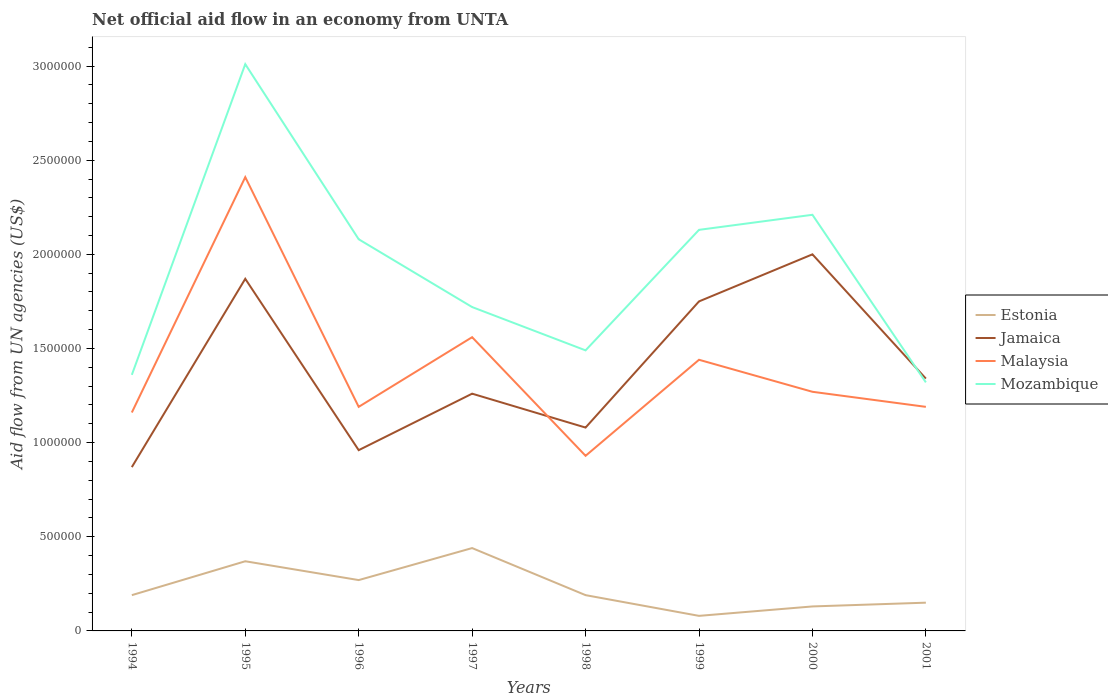Does the line corresponding to Jamaica intersect with the line corresponding to Estonia?
Your response must be concise. No. Is the number of lines equal to the number of legend labels?
Your answer should be very brief. Yes. Across all years, what is the maximum net official aid flow in Mozambique?
Offer a terse response. 1.32e+06. What is the total net official aid flow in Jamaica in the graph?
Your answer should be compact. -4.90e+05. What is the difference between the highest and the second highest net official aid flow in Malaysia?
Keep it short and to the point. 1.48e+06. Are the values on the major ticks of Y-axis written in scientific E-notation?
Provide a succinct answer. No. Does the graph contain any zero values?
Offer a very short reply. No. Does the graph contain grids?
Your answer should be compact. No. How are the legend labels stacked?
Provide a succinct answer. Vertical. What is the title of the graph?
Give a very brief answer. Net official aid flow in an economy from UNTA. What is the label or title of the Y-axis?
Make the answer very short. Aid flow from UN agencies (US$). What is the Aid flow from UN agencies (US$) of Jamaica in 1994?
Offer a very short reply. 8.70e+05. What is the Aid flow from UN agencies (US$) in Malaysia in 1994?
Keep it short and to the point. 1.16e+06. What is the Aid flow from UN agencies (US$) in Mozambique in 1994?
Make the answer very short. 1.36e+06. What is the Aid flow from UN agencies (US$) of Estonia in 1995?
Give a very brief answer. 3.70e+05. What is the Aid flow from UN agencies (US$) of Jamaica in 1995?
Ensure brevity in your answer.  1.87e+06. What is the Aid flow from UN agencies (US$) of Malaysia in 1995?
Provide a succinct answer. 2.41e+06. What is the Aid flow from UN agencies (US$) of Mozambique in 1995?
Ensure brevity in your answer.  3.01e+06. What is the Aid flow from UN agencies (US$) in Jamaica in 1996?
Your answer should be very brief. 9.60e+05. What is the Aid flow from UN agencies (US$) in Malaysia in 1996?
Provide a short and direct response. 1.19e+06. What is the Aid flow from UN agencies (US$) of Mozambique in 1996?
Your answer should be very brief. 2.08e+06. What is the Aid flow from UN agencies (US$) of Jamaica in 1997?
Provide a short and direct response. 1.26e+06. What is the Aid flow from UN agencies (US$) in Malaysia in 1997?
Offer a terse response. 1.56e+06. What is the Aid flow from UN agencies (US$) in Mozambique in 1997?
Offer a very short reply. 1.72e+06. What is the Aid flow from UN agencies (US$) in Jamaica in 1998?
Give a very brief answer. 1.08e+06. What is the Aid flow from UN agencies (US$) of Malaysia in 1998?
Offer a terse response. 9.30e+05. What is the Aid flow from UN agencies (US$) in Mozambique in 1998?
Offer a very short reply. 1.49e+06. What is the Aid flow from UN agencies (US$) of Estonia in 1999?
Keep it short and to the point. 8.00e+04. What is the Aid flow from UN agencies (US$) of Jamaica in 1999?
Your answer should be compact. 1.75e+06. What is the Aid flow from UN agencies (US$) in Malaysia in 1999?
Give a very brief answer. 1.44e+06. What is the Aid flow from UN agencies (US$) in Mozambique in 1999?
Provide a short and direct response. 2.13e+06. What is the Aid flow from UN agencies (US$) in Malaysia in 2000?
Offer a very short reply. 1.27e+06. What is the Aid flow from UN agencies (US$) of Mozambique in 2000?
Keep it short and to the point. 2.21e+06. What is the Aid flow from UN agencies (US$) of Jamaica in 2001?
Provide a succinct answer. 1.34e+06. What is the Aid flow from UN agencies (US$) in Malaysia in 2001?
Ensure brevity in your answer.  1.19e+06. What is the Aid flow from UN agencies (US$) of Mozambique in 2001?
Offer a very short reply. 1.32e+06. Across all years, what is the maximum Aid flow from UN agencies (US$) of Estonia?
Give a very brief answer. 4.40e+05. Across all years, what is the maximum Aid flow from UN agencies (US$) of Jamaica?
Offer a very short reply. 2.00e+06. Across all years, what is the maximum Aid flow from UN agencies (US$) of Malaysia?
Provide a succinct answer. 2.41e+06. Across all years, what is the maximum Aid flow from UN agencies (US$) of Mozambique?
Ensure brevity in your answer.  3.01e+06. Across all years, what is the minimum Aid flow from UN agencies (US$) in Jamaica?
Offer a very short reply. 8.70e+05. Across all years, what is the minimum Aid flow from UN agencies (US$) of Malaysia?
Your answer should be compact. 9.30e+05. Across all years, what is the minimum Aid flow from UN agencies (US$) of Mozambique?
Keep it short and to the point. 1.32e+06. What is the total Aid flow from UN agencies (US$) in Estonia in the graph?
Provide a short and direct response. 1.82e+06. What is the total Aid flow from UN agencies (US$) of Jamaica in the graph?
Your answer should be very brief. 1.11e+07. What is the total Aid flow from UN agencies (US$) in Malaysia in the graph?
Keep it short and to the point. 1.12e+07. What is the total Aid flow from UN agencies (US$) in Mozambique in the graph?
Your answer should be very brief. 1.53e+07. What is the difference between the Aid flow from UN agencies (US$) in Estonia in 1994 and that in 1995?
Your answer should be very brief. -1.80e+05. What is the difference between the Aid flow from UN agencies (US$) in Jamaica in 1994 and that in 1995?
Give a very brief answer. -1.00e+06. What is the difference between the Aid flow from UN agencies (US$) of Malaysia in 1994 and that in 1995?
Provide a short and direct response. -1.25e+06. What is the difference between the Aid flow from UN agencies (US$) in Mozambique in 1994 and that in 1995?
Offer a terse response. -1.65e+06. What is the difference between the Aid flow from UN agencies (US$) of Estonia in 1994 and that in 1996?
Provide a short and direct response. -8.00e+04. What is the difference between the Aid flow from UN agencies (US$) in Jamaica in 1994 and that in 1996?
Your answer should be very brief. -9.00e+04. What is the difference between the Aid flow from UN agencies (US$) in Mozambique in 1994 and that in 1996?
Your answer should be compact. -7.20e+05. What is the difference between the Aid flow from UN agencies (US$) in Jamaica in 1994 and that in 1997?
Your response must be concise. -3.90e+05. What is the difference between the Aid flow from UN agencies (US$) of Malaysia in 1994 and that in 1997?
Your answer should be very brief. -4.00e+05. What is the difference between the Aid flow from UN agencies (US$) of Mozambique in 1994 and that in 1997?
Keep it short and to the point. -3.60e+05. What is the difference between the Aid flow from UN agencies (US$) in Malaysia in 1994 and that in 1998?
Give a very brief answer. 2.30e+05. What is the difference between the Aid flow from UN agencies (US$) in Mozambique in 1994 and that in 1998?
Your answer should be very brief. -1.30e+05. What is the difference between the Aid flow from UN agencies (US$) of Estonia in 1994 and that in 1999?
Provide a succinct answer. 1.10e+05. What is the difference between the Aid flow from UN agencies (US$) in Jamaica in 1994 and that in 1999?
Your response must be concise. -8.80e+05. What is the difference between the Aid flow from UN agencies (US$) of Malaysia in 1994 and that in 1999?
Your answer should be very brief. -2.80e+05. What is the difference between the Aid flow from UN agencies (US$) of Mozambique in 1994 and that in 1999?
Make the answer very short. -7.70e+05. What is the difference between the Aid flow from UN agencies (US$) of Jamaica in 1994 and that in 2000?
Provide a succinct answer. -1.13e+06. What is the difference between the Aid flow from UN agencies (US$) in Mozambique in 1994 and that in 2000?
Your response must be concise. -8.50e+05. What is the difference between the Aid flow from UN agencies (US$) of Estonia in 1994 and that in 2001?
Give a very brief answer. 4.00e+04. What is the difference between the Aid flow from UN agencies (US$) of Jamaica in 1994 and that in 2001?
Offer a terse response. -4.70e+05. What is the difference between the Aid flow from UN agencies (US$) of Estonia in 1995 and that in 1996?
Your answer should be very brief. 1.00e+05. What is the difference between the Aid flow from UN agencies (US$) in Jamaica in 1995 and that in 1996?
Keep it short and to the point. 9.10e+05. What is the difference between the Aid flow from UN agencies (US$) in Malaysia in 1995 and that in 1996?
Make the answer very short. 1.22e+06. What is the difference between the Aid flow from UN agencies (US$) in Mozambique in 1995 and that in 1996?
Your answer should be very brief. 9.30e+05. What is the difference between the Aid flow from UN agencies (US$) of Malaysia in 1995 and that in 1997?
Offer a very short reply. 8.50e+05. What is the difference between the Aid flow from UN agencies (US$) in Mozambique in 1995 and that in 1997?
Offer a very short reply. 1.29e+06. What is the difference between the Aid flow from UN agencies (US$) of Jamaica in 1995 and that in 1998?
Provide a short and direct response. 7.90e+05. What is the difference between the Aid flow from UN agencies (US$) in Malaysia in 1995 and that in 1998?
Your answer should be very brief. 1.48e+06. What is the difference between the Aid flow from UN agencies (US$) in Mozambique in 1995 and that in 1998?
Offer a very short reply. 1.52e+06. What is the difference between the Aid flow from UN agencies (US$) of Malaysia in 1995 and that in 1999?
Your response must be concise. 9.70e+05. What is the difference between the Aid flow from UN agencies (US$) of Mozambique in 1995 and that in 1999?
Provide a short and direct response. 8.80e+05. What is the difference between the Aid flow from UN agencies (US$) in Malaysia in 1995 and that in 2000?
Make the answer very short. 1.14e+06. What is the difference between the Aid flow from UN agencies (US$) of Mozambique in 1995 and that in 2000?
Provide a short and direct response. 8.00e+05. What is the difference between the Aid flow from UN agencies (US$) of Jamaica in 1995 and that in 2001?
Your response must be concise. 5.30e+05. What is the difference between the Aid flow from UN agencies (US$) of Malaysia in 1995 and that in 2001?
Provide a short and direct response. 1.22e+06. What is the difference between the Aid flow from UN agencies (US$) in Mozambique in 1995 and that in 2001?
Your response must be concise. 1.69e+06. What is the difference between the Aid flow from UN agencies (US$) in Malaysia in 1996 and that in 1997?
Give a very brief answer. -3.70e+05. What is the difference between the Aid flow from UN agencies (US$) in Estonia in 1996 and that in 1998?
Your answer should be compact. 8.00e+04. What is the difference between the Aid flow from UN agencies (US$) in Jamaica in 1996 and that in 1998?
Give a very brief answer. -1.20e+05. What is the difference between the Aid flow from UN agencies (US$) in Malaysia in 1996 and that in 1998?
Make the answer very short. 2.60e+05. What is the difference between the Aid flow from UN agencies (US$) in Mozambique in 1996 and that in 1998?
Ensure brevity in your answer.  5.90e+05. What is the difference between the Aid flow from UN agencies (US$) in Jamaica in 1996 and that in 1999?
Offer a very short reply. -7.90e+05. What is the difference between the Aid flow from UN agencies (US$) in Mozambique in 1996 and that in 1999?
Your answer should be compact. -5.00e+04. What is the difference between the Aid flow from UN agencies (US$) of Estonia in 1996 and that in 2000?
Provide a short and direct response. 1.40e+05. What is the difference between the Aid flow from UN agencies (US$) of Jamaica in 1996 and that in 2000?
Your answer should be very brief. -1.04e+06. What is the difference between the Aid flow from UN agencies (US$) of Malaysia in 1996 and that in 2000?
Provide a succinct answer. -8.00e+04. What is the difference between the Aid flow from UN agencies (US$) in Mozambique in 1996 and that in 2000?
Offer a terse response. -1.30e+05. What is the difference between the Aid flow from UN agencies (US$) of Estonia in 1996 and that in 2001?
Provide a succinct answer. 1.20e+05. What is the difference between the Aid flow from UN agencies (US$) of Jamaica in 1996 and that in 2001?
Your answer should be very brief. -3.80e+05. What is the difference between the Aid flow from UN agencies (US$) of Mozambique in 1996 and that in 2001?
Keep it short and to the point. 7.60e+05. What is the difference between the Aid flow from UN agencies (US$) of Malaysia in 1997 and that in 1998?
Keep it short and to the point. 6.30e+05. What is the difference between the Aid flow from UN agencies (US$) of Estonia in 1997 and that in 1999?
Make the answer very short. 3.60e+05. What is the difference between the Aid flow from UN agencies (US$) in Jamaica in 1997 and that in 1999?
Offer a terse response. -4.90e+05. What is the difference between the Aid flow from UN agencies (US$) of Mozambique in 1997 and that in 1999?
Provide a short and direct response. -4.10e+05. What is the difference between the Aid flow from UN agencies (US$) in Jamaica in 1997 and that in 2000?
Your response must be concise. -7.40e+05. What is the difference between the Aid flow from UN agencies (US$) of Mozambique in 1997 and that in 2000?
Offer a very short reply. -4.90e+05. What is the difference between the Aid flow from UN agencies (US$) of Estonia in 1997 and that in 2001?
Offer a terse response. 2.90e+05. What is the difference between the Aid flow from UN agencies (US$) of Mozambique in 1997 and that in 2001?
Give a very brief answer. 4.00e+05. What is the difference between the Aid flow from UN agencies (US$) of Jamaica in 1998 and that in 1999?
Offer a very short reply. -6.70e+05. What is the difference between the Aid flow from UN agencies (US$) in Malaysia in 1998 and that in 1999?
Keep it short and to the point. -5.10e+05. What is the difference between the Aid flow from UN agencies (US$) in Mozambique in 1998 and that in 1999?
Offer a very short reply. -6.40e+05. What is the difference between the Aid flow from UN agencies (US$) of Jamaica in 1998 and that in 2000?
Offer a very short reply. -9.20e+05. What is the difference between the Aid flow from UN agencies (US$) in Malaysia in 1998 and that in 2000?
Offer a very short reply. -3.40e+05. What is the difference between the Aid flow from UN agencies (US$) in Mozambique in 1998 and that in 2000?
Ensure brevity in your answer.  -7.20e+05. What is the difference between the Aid flow from UN agencies (US$) of Estonia in 1998 and that in 2001?
Make the answer very short. 4.00e+04. What is the difference between the Aid flow from UN agencies (US$) of Jamaica in 1998 and that in 2001?
Keep it short and to the point. -2.60e+05. What is the difference between the Aid flow from UN agencies (US$) in Mozambique in 1999 and that in 2000?
Provide a short and direct response. -8.00e+04. What is the difference between the Aid flow from UN agencies (US$) in Estonia in 1999 and that in 2001?
Your answer should be very brief. -7.00e+04. What is the difference between the Aid flow from UN agencies (US$) of Jamaica in 1999 and that in 2001?
Your answer should be compact. 4.10e+05. What is the difference between the Aid flow from UN agencies (US$) in Malaysia in 1999 and that in 2001?
Offer a very short reply. 2.50e+05. What is the difference between the Aid flow from UN agencies (US$) in Mozambique in 1999 and that in 2001?
Your response must be concise. 8.10e+05. What is the difference between the Aid flow from UN agencies (US$) of Mozambique in 2000 and that in 2001?
Provide a short and direct response. 8.90e+05. What is the difference between the Aid flow from UN agencies (US$) in Estonia in 1994 and the Aid flow from UN agencies (US$) in Jamaica in 1995?
Make the answer very short. -1.68e+06. What is the difference between the Aid flow from UN agencies (US$) in Estonia in 1994 and the Aid flow from UN agencies (US$) in Malaysia in 1995?
Keep it short and to the point. -2.22e+06. What is the difference between the Aid flow from UN agencies (US$) in Estonia in 1994 and the Aid flow from UN agencies (US$) in Mozambique in 1995?
Give a very brief answer. -2.82e+06. What is the difference between the Aid flow from UN agencies (US$) in Jamaica in 1994 and the Aid flow from UN agencies (US$) in Malaysia in 1995?
Provide a short and direct response. -1.54e+06. What is the difference between the Aid flow from UN agencies (US$) of Jamaica in 1994 and the Aid flow from UN agencies (US$) of Mozambique in 1995?
Make the answer very short. -2.14e+06. What is the difference between the Aid flow from UN agencies (US$) of Malaysia in 1994 and the Aid flow from UN agencies (US$) of Mozambique in 1995?
Make the answer very short. -1.85e+06. What is the difference between the Aid flow from UN agencies (US$) in Estonia in 1994 and the Aid flow from UN agencies (US$) in Jamaica in 1996?
Provide a succinct answer. -7.70e+05. What is the difference between the Aid flow from UN agencies (US$) of Estonia in 1994 and the Aid flow from UN agencies (US$) of Malaysia in 1996?
Give a very brief answer. -1.00e+06. What is the difference between the Aid flow from UN agencies (US$) in Estonia in 1994 and the Aid flow from UN agencies (US$) in Mozambique in 1996?
Give a very brief answer. -1.89e+06. What is the difference between the Aid flow from UN agencies (US$) in Jamaica in 1994 and the Aid flow from UN agencies (US$) in Malaysia in 1996?
Provide a short and direct response. -3.20e+05. What is the difference between the Aid flow from UN agencies (US$) in Jamaica in 1994 and the Aid flow from UN agencies (US$) in Mozambique in 1996?
Ensure brevity in your answer.  -1.21e+06. What is the difference between the Aid flow from UN agencies (US$) in Malaysia in 1994 and the Aid flow from UN agencies (US$) in Mozambique in 1996?
Provide a short and direct response. -9.20e+05. What is the difference between the Aid flow from UN agencies (US$) in Estonia in 1994 and the Aid flow from UN agencies (US$) in Jamaica in 1997?
Ensure brevity in your answer.  -1.07e+06. What is the difference between the Aid flow from UN agencies (US$) in Estonia in 1994 and the Aid flow from UN agencies (US$) in Malaysia in 1997?
Offer a very short reply. -1.37e+06. What is the difference between the Aid flow from UN agencies (US$) in Estonia in 1994 and the Aid flow from UN agencies (US$) in Mozambique in 1997?
Ensure brevity in your answer.  -1.53e+06. What is the difference between the Aid flow from UN agencies (US$) of Jamaica in 1994 and the Aid flow from UN agencies (US$) of Malaysia in 1997?
Provide a succinct answer. -6.90e+05. What is the difference between the Aid flow from UN agencies (US$) in Jamaica in 1994 and the Aid flow from UN agencies (US$) in Mozambique in 1997?
Your answer should be compact. -8.50e+05. What is the difference between the Aid flow from UN agencies (US$) of Malaysia in 1994 and the Aid flow from UN agencies (US$) of Mozambique in 1997?
Provide a succinct answer. -5.60e+05. What is the difference between the Aid flow from UN agencies (US$) in Estonia in 1994 and the Aid flow from UN agencies (US$) in Jamaica in 1998?
Ensure brevity in your answer.  -8.90e+05. What is the difference between the Aid flow from UN agencies (US$) in Estonia in 1994 and the Aid flow from UN agencies (US$) in Malaysia in 1998?
Ensure brevity in your answer.  -7.40e+05. What is the difference between the Aid flow from UN agencies (US$) of Estonia in 1994 and the Aid flow from UN agencies (US$) of Mozambique in 1998?
Your answer should be compact. -1.30e+06. What is the difference between the Aid flow from UN agencies (US$) in Jamaica in 1994 and the Aid flow from UN agencies (US$) in Mozambique in 1998?
Provide a succinct answer. -6.20e+05. What is the difference between the Aid flow from UN agencies (US$) in Malaysia in 1994 and the Aid flow from UN agencies (US$) in Mozambique in 1998?
Your answer should be very brief. -3.30e+05. What is the difference between the Aid flow from UN agencies (US$) of Estonia in 1994 and the Aid flow from UN agencies (US$) of Jamaica in 1999?
Offer a very short reply. -1.56e+06. What is the difference between the Aid flow from UN agencies (US$) in Estonia in 1994 and the Aid flow from UN agencies (US$) in Malaysia in 1999?
Ensure brevity in your answer.  -1.25e+06. What is the difference between the Aid flow from UN agencies (US$) in Estonia in 1994 and the Aid flow from UN agencies (US$) in Mozambique in 1999?
Provide a short and direct response. -1.94e+06. What is the difference between the Aid flow from UN agencies (US$) in Jamaica in 1994 and the Aid flow from UN agencies (US$) in Malaysia in 1999?
Your response must be concise. -5.70e+05. What is the difference between the Aid flow from UN agencies (US$) of Jamaica in 1994 and the Aid flow from UN agencies (US$) of Mozambique in 1999?
Ensure brevity in your answer.  -1.26e+06. What is the difference between the Aid flow from UN agencies (US$) in Malaysia in 1994 and the Aid flow from UN agencies (US$) in Mozambique in 1999?
Keep it short and to the point. -9.70e+05. What is the difference between the Aid flow from UN agencies (US$) in Estonia in 1994 and the Aid flow from UN agencies (US$) in Jamaica in 2000?
Provide a succinct answer. -1.81e+06. What is the difference between the Aid flow from UN agencies (US$) in Estonia in 1994 and the Aid flow from UN agencies (US$) in Malaysia in 2000?
Ensure brevity in your answer.  -1.08e+06. What is the difference between the Aid flow from UN agencies (US$) in Estonia in 1994 and the Aid flow from UN agencies (US$) in Mozambique in 2000?
Provide a short and direct response. -2.02e+06. What is the difference between the Aid flow from UN agencies (US$) in Jamaica in 1994 and the Aid flow from UN agencies (US$) in Malaysia in 2000?
Give a very brief answer. -4.00e+05. What is the difference between the Aid flow from UN agencies (US$) in Jamaica in 1994 and the Aid flow from UN agencies (US$) in Mozambique in 2000?
Your answer should be compact. -1.34e+06. What is the difference between the Aid flow from UN agencies (US$) of Malaysia in 1994 and the Aid flow from UN agencies (US$) of Mozambique in 2000?
Your response must be concise. -1.05e+06. What is the difference between the Aid flow from UN agencies (US$) of Estonia in 1994 and the Aid flow from UN agencies (US$) of Jamaica in 2001?
Offer a very short reply. -1.15e+06. What is the difference between the Aid flow from UN agencies (US$) of Estonia in 1994 and the Aid flow from UN agencies (US$) of Mozambique in 2001?
Ensure brevity in your answer.  -1.13e+06. What is the difference between the Aid flow from UN agencies (US$) in Jamaica in 1994 and the Aid flow from UN agencies (US$) in Malaysia in 2001?
Your response must be concise. -3.20e+05. What is the difference between the Aid flow from UN agencies (US$) of Jamaica in 1994 and the Aid flow from UN agencies (US$) of Mozambique in 2001?
Give a very brief answer. -4.50e+05. What is the difference between the Aid flow from UN agencies (US$) in Estonia in 1995 and the Aid flow from UN agencies (US$) in Jamaica in 1996?
Ensure brevity in your answer.  -5.90e+05. What is the difference between the Aid flow from UN agencies (US$) of Estonia in 1995 and the Aid flow from UN agencies (US$) of Malaysia in 1996?
Keep it short and to the point. -8.20e+05. What is the difference between the Aid flow from UN agencies (US$) of Estonia in 1995 and the Aid flow from UN agencies (US$) of Mozambique in 1996?
Make the answer very short. -1.71e+06. What is the difference between the Aid flow from UN agencies (US$) in Jamaica in 1995 and the Aid flow from UN agencies (US$) in Malaysia in 1996?
Your response must be concise. 6.80e+05. What is the difference between the Aid flow from UN agencies (US$) in Estonia in 1995 and the Aid flow from UN agencies (US$) in Jamaica in 1997?
Offer a very short reply. -8.90e+05. What is the difference between the Aid flow from UN agencies (US$) of Estonia in 1995 and the Aid flow from UN agencies (US$) of Malaysia in 1997?
Your answer should be very brief. -1.19e+06. What is the difference between the Aid flow from UN agencies (US$) in Estonia in 1995 and the Aid flow from UN agencies (US$) in Mozambique in 1997?
Provide a succinct answer. -1.35e+06. What is the difference between the Aid flow from UN agencies (US$) in Malaysia in 1995 and the Aid flow from UN agencies (US$) in Mozambique in 1997?
Ensure brevity in your answer.  6.90e+05. What is the difference between the Aid flow from UN agencies (US$) of Estonia in 1995 and the Aid flow from UN agencies (US$) of Jamaica in 1998?
Provide a short and direct response. -7.10e+05. What is the difference between the Aid flow from UN agencies (US$) of Estonia in 1995 and the Aid flow from UN agencies (US$) of Malaysia in 1998?
Ensure brevity in your answer.  -5.60e+05. What is the difference between the Aid flow from UN agencies (US$) of Estonia in 1995 and the Aid flow from UN agencies (US$) of Mozambique in 1998?
Offer a terse response. -1.12e+06. What is the difference between the Aid flow from UN agencies (US$) in Jamaica in 1995 and the Aid flow from UN agencies (US$) in Malaysia in 1998?
Ensure brevity in your answer.  9.40e+05. What is the difference between the Aid flow from UN agencies (US$) in Malaysia in 1995 and the Aid flow from UN agencies (US$) in Mozambique in 1998?
Provide a succinct answer. 9.20e+05. What is the difference between the Aid flow from UN agencies (US$) of Estonia in 1995 and the Aid flow from UN agencies (US$) of Jamaica in 1999?
Your response must be concise. -1.38e+06. What is the difference between the Aid flow from UN agencies (US$) of Estonia in 1995 and the Aid flow from UN agencies (US$) of Malaysia in 1999?
Your answer should be compact. -1.07e+06. What is the difference between the Aid flow from UN agencies (US$) of Estonia in 1995 and the Aid flow from UN agencies (US$) of Mozambique in 1999?
Make the answer very short. -1.76e+06. What is the difference between the Aid flow from UN agencies (US$) of Jamaica in 1995 and the Aid flow from UN agencies (US$) of Malaysia in 1999?
Your answer should be very brief. 4.30e+05. What is the difference between the Aid flow from UN agencies (US$) in Estonia in 1995 and the Aid flow from UN agencies (US$) in Jamaica in 2000?
Your answer should be very brief. -1.63e+06. What is the difference between the Aid flow from UN agencies (US$) of Estonia in 1995 and the Aid flow from UN agencies (US$) of Malaysia in 2000?
Your answer should be very brief. -9.00e+05. What is the difference between the Aid flow from UN agencies (US$) in Estonia in 1995 and the Aid flow from UN agencies (US$) in Mozambique in 2000?
Your answer should be compact. -1.84e+06. What is the difference between the Aid flow from UN agencies (US$) of Jamaica in 1995 and the Aid flow from UN agencies (US$) of Mozambique in 2000?
Make the answer very short. -3.40e+05. What is the difference between the Aid flow from UN agencies (US$) of Malaysia in 1995 and the Aid flow from UN agencies (US$) of Mozambique in 2000?
Offer a very short reply. 2.00e+05. What is the difference between the Aid flow from UN agencies (US$) of Estonia in 1995 and the Aid flow from UN agencies (US$) of Jamaica in 2001?
Keep it short and to the point. -9.70e+05. What is the difference between the Aid flow from UN agencies (US$) in Estonia in 1995 and the Aid flow from UN agencies (US$) in Malaysia in 2001?
Offer a terse response. -8.20e+05. What is the difference between the Aid flow from UN agencies (US$) of Estonia in 1995 and the Aid flow from UN agencies (US$) of Mozambique in 2001?
Offer a very short reply. -9.50e+05. What is the difference between the Aid flow from UN agencies (US$) of Jamaica in 1995 and the Aid flow from UN agencies (US$) of Malaysia in 2001?
Your answer should be very brief. 6.80e+05. What is the difference between the Aid flow from UN agencies (US$) in Malaysia in 1995 and the Aid flow from UN agencies (US$) in Mozambique in 2001?
Your answer should be very brief. 1.09e+06. What is the difference between the Aid flow from UN agencies (US$) in Estonia in 1996 and the Aid flow from UN agencies (US$) in Jamaica in 1997?
Your answer should be very brief. -9.90e+05. What is the difference between the Aid flow from UN agencies (US$) of Estonia in 1996 and the Aid flow from UN agencies (US$) of Malaysia in 1997?
Ensure brevity in your answer.  -1.29e+06. What is the difference between the Aid flow from UN agencies (US$) in Estonia in 1996 and the Aid flow from UN agencies (US$) in Mozambique in 1997?
Give a very brief answer. -1.45e+06. What is the difference between the Aid flow from UN agencies (US$) of Jamaica in 1996 and the Aid flow from UN agencies (US$) of Malaysia in 1997?
Make the answer very short. -6.00e+05. What is the difference between the Aid flow from UN agencies (US$) in Jamaica in 1996 and the Aid flow from UN agencies (US$) in Mozambique in 1997?
Make the answer very short. -7.60e+05. What is the difference between the Aid flow from UN agencies (US$) of Malaysia in 1996 and the Aid flow from UN agencies (US$) of Mozambique in 1997?
Make the answer very short. -5.30e+05. What is the difference between the Aid flow from UN agencies (US$) in Estonia in 1996 and the Aid flow from UN agencies (US$) in Jamaica in 1998?
Your answer should be compact. -8.10e+05. What is the difference between the Aid flow from UN agencies (US$) of Estonia in 1996 and the Aid flow from UN agencies (US$) of Malaysia in 1998?
Your answer should be compact. -6.60e+05. What is the difference between the Aid flow from UN agencies (US$) of Estonia in 1996 and the Aid flow from UN agencies (US$) of Mozambique in 1998?
Your response must be concise. -1.22e+06. What is the difference between the Aid flow from UN agencies (US$) of Jamaica in 1996 and the Aid flow from UN agencies (US$) of Mozambique in 1998?
Give a very brief answer. -5.30e+05. What is the difference between the Aid flow from UN agencies (US$) of Estonia in 1996 and the Aid flow from UN agencies (US$) of Jamaica in 1999?
Make the answer very short. -1.48e+06. What is the difference between the Aid flow from UN agencies (US$) of Estonia in 1996 and the Aid flow from UN agencies (US$) of Malaysia in 1999?
Give a very brief answer. -1.17e+06. What is the difference between the Aid flow from UN agencies (US$) of Estonia in 1996 and the Aid flow from UN agencies (US$) of Mozambique in 1999?
Make the answer very short. -1.86e+06. What is the difference between the Aid flow from UN agencies (US$) in Jamaica in 1996 and the Aid flow from UN agencies (US$) in Malaysia in 1999?
Give a very brief answer. -4.80e+05. What is the difference between the Aid flow from UN agencies (US$) in Jamaica in 1996 and the Aid flow from UN agencies (US$) in Mozambique in 1999?
Provide a succinct answer. -1.17e+06. What is the difference between the Aid flow from UN agencies (US$) of Malaysia in 1996 and the Aid flow from UN agencies (US$) of Mozambique in 1999?
Give a very brief answer. -9.40e+05. What is the difference between the Aid flow from UN agencies (US$) of Estonia in 1996 and the Aid flow from UN agencies (US$) of Jamaica in 2000?
Offer a terse response. -1.73e+06. What is the difference between the Aid flow from UN agencies (US$) in Estonia in 1996 and the Aid flow from UN agencies (US$) in Malaysia in 2000?
Your answer should be compact. -1.00e+06. What is the difference between the Aid flow from UN agencies (US$) of Estonia in 1996 and the Aid flow from UN agencies (US$) of Mozambique in 2000?
Provide a succinct answer. -1.94e+06. What is the difference between the Aid flow from UN agencies (US$) of Jamaica in 1996 and the Aid flow from UN agencies (US$) of Malaysia in 2000?
Provide a succinct answer. -3.10e+05. What is the difference between the Aid flow from UN agencies (US$) of Jamaica in 1996 and the Aid flow from UN agencies (US$) of Mozambique in 2000?
Offer a very short reply. -1.25e+06. What is the difference between the Aid flow from UN agencies (US$) of Malaysia in 1996 and the Aid flow from UN agencies (US$) of Mozambique in 2000?
Provide a succinct answer. -1.02e+06. What is the difference between the Aid flow from UN agencies (US$) of Estonia in 1996 and the Aid flow from UN agencies (US$) of Jamaica in 2001?
Offer a terse response. -1.07e+06. What is the difference between the Aid flow from UN agencies (US$) in Estonia in 1996 and the Aid flow from UN agencies (US$) in Malaysia in 2001?
Make the answer very short. -9.20e+05. What is the difference between the Aid flow from UN agencies (US$) of Estonia in 1996 and the Aid flow from UN agencies (US$) of Mozambique in 2001?
Give a very brief answer. -1.05e+06. What is the difference between the Aid flow from UN agencies (US$) of Jamaica in 1996 and the Aid flow from UN agencies (US$) of Malaysia in 2001?
Offer a terse response. -2.30e+05. What is the difference between the Aid flow from UN agencies (US$) in Jamaica in 1996 and the Aid flow from UN agencies (US$) in Mozambique in 2001?
Ensure brevity in your answer.  -3.60e+05. What is the difference between the Aid flow from UN agencies (US$) in Estonia in 1997 and the Aid flow from UN agencies (US$) in Jamaica in 1998?
Make the answer very short. -6.40e+05. What is the difference between the Aid flow from UN agencies (US$) of Estonia in 1997 and the Aid flow from UN agencies (US$) of Malaysia in 1998?
Offer a very short reply. -4.90e+05. What is the difference between the Aid flow from UN agencies (US$) of Estonia in 1997 and the Aid flow from UN agencies (US$) of Mozambique in 1998?
Provide a short and direct response. -1.05e+06. What is the difference between the Aid flow from UN agencies (US$) in Malaysia in 1997 and the Aid flow from UN agencies (US$) in Mozambique in 1998?
Make the answer very short. 7.00e+04. What is the difference between the Aid flow from UN agencies (US$) of Estonia in 1997 and the Aid flow from UN agencies (US$) of Jamaica in 1999?
Keep it short and to the point. -1.31e+06. What is the difference between the Aid flow from UN agencies (US$) in Estonia in 1997 and the Aid flow from UN agencies (US$) in Malaysia in 1999?
Provide a short and direct response. -1.00e+06. What is the difference between the Aid flow from UN agencies (US$) in Estonia in 1997 and the Aid flow from UN agencies (US$) in Mozambique in 1999?
Keep it short and to the point. -1.69e+06. What is the difference between the Aid flow from UN agencies (US$) of Jamaica in 1997 and the Aid flow from UN agencies (US$) of Malaysia in 1999?
Your response must be concise. -1.80e+05. What is the difference between the Aid flow from UN agencies (US$) in Jamaica in 1997 and the Aid flow from UN agencies (US$) in Mozambique in 1999?
Your answer should be compact. -8.70e+05. What is the difference between the Aid flow from UN agencies (US$) of Malaysia in 1997 and the Aid flow from UN agencies (US$) of Mozambique in 1999?
Offer a terse response. -5.70e+05. What is the difference between the Aid flow from UN agencies (US$) of Estonia in 1997 and the Aid flow from UN agencies (US$) of Jamaica in 2000?
Provide a succinct answer. -1.56e+06. What is the difference between the Aid flow from UN agencies (US$) in Estonia in 1997 and the Aid flow from UN agencies (US$) in Malaysia in 2000?
Give a very brief answer. -8.30e+05. What is the difference between the Aid flow from UN agencies (US$) of Estonia in 1997 and the Aid flow from UN agencies (US$) of Mozambique in 2000?
Ensure brevity in your answer.  -1.77e+06. What is the difference between the Aid flow from UN agencies (US$) in Jamaica in 1997 and the Aid flow from UN agencies (US$) in Malaysia in 2000?
Your answer should be compact. -10000. What is the difference between the Aid flow from UN agencies (US$) in Jamaica in 1997 and the Aid flow from UN agencies (US$) in Mozambique in 2000?
Keep it short and to the point. -9.50e+05. What is the difference between the Aid flow from UN agencies (US$) in Malaysia in 1997 and the Aid flow from UN agencies (US$) in Mozambique in 2000?
Your answer should be compact. -6.50e+05. What is the difference between the Aid flow from UN agencies (US$) in Estonia in 1997 and the Aid flow from UN agencies (US$) in Jamaica in 2001?
Keep it short and to the point. -9.00e+05. What is the difference between the Aid flow from UN agencies (US$) of Estonia in 1997 and the Aid flow from UN agencies (US$) of Malaysia in 2001?
Provide a succinct answer. -7.50e+05. What is the difference between the Aid flow from UN agencies (US$) in Estonia in 1997 and the Aid flow from UN agencies (US$) in Mozambique in 2001?
Keep it short and to the point. -8.80e+05. What is the difference between the Aid flow from UN agencies (US$) in Jamaica in 1997 and the Aid flow from UN agencies (US$) in Malaysia in 2001?
Keep it short and to the point. 7.00e+04. What is the difference between the Aid flow from UN agencies (US$) in Jamaica in 1997 and the Aid flow from UN agencies (US$) in Mozambique in 2001?
Make the answer very short. -6.00e+04. What is the difference between the Aid flow from UN agencies (US$) in Malaysia in 1997 and the Aid flow from UN agencies (US$) in Mozambique in 2001?
Offer a terse response. 2.40e+05. What is the difference between the Aid flow from UN agencies (US$) in Estonia in 1998 and the Aid flow from UN agencies (US$) in Jamaica in 1999?
Provide a short and direct response. -1.56e+06. What is the difference between the Aid flow from UN agencies (US$) of Estonia in 1998 and the Aid flow from UN agencies (US$) of Malaysia in 1999?
Offer a terse response. -1.25e+06. What is the difference between the Aid flow from UN agencies (US$) in Estonia in 1998 and the Aid flow from UN agencies (US$) in Mozambique in 1999?
Provide a short and direct response. -1.94e+06. What is the difference between the Aid flow from UN agencies (US$) of Jamaica in 1998 and the Aid flow from UN agencies (US$) of Malaysia in 1999?
Make the answer very short. -3.60e+05. What is the difference between the Aid flow from UN agencies (US$) of Jamaica in 1998 and the Aid flow from UN agencies (US$) of Mozambique in 1999?
Give a very brief answer. -1.05e+06. What is the difference between the Aid flow from UN agencies (US$) in Malaysia in 1998 and the Aid flow from UN agencies (US$) in Mozambique in 1999?
Provide a succinct answer. -1.20e+06. What is the difference between the Aid flow from UN agencies (US$) of Estonia in 1998 and the Aid flow from UN agencies (US$) of Jamaica in 2000?
Provide a succinct answer. -1.81e+06. What is the difference between the Aid flow from UN agencies (US$) in Estonia in 1998 and the Aid flow from UN agencies (US$) in Malaysia in 2000?
Keep it short and to the point. -1.08e+06. What is the difference between the Aid flow from UN agencies (US$) of Estonia in 1998 and the Aid flow from UN agencies (US$) of Mozambique in 2000?
Provide a short and direct response. -2.02e+06. What is the difference between the Aid flow from UN agencies (US$) in Jamaica in 1998 and the Aid flow from UN agencies (US$) in Malaysia in 2000?
Keep it short and to the point. -1.90e+05. What is the difference between the Aid flow from UN agencies (US$) of Jamaica in 1998 and the Aid flow from UN agencies (US$) of Mozambique in 2000?
Provide a succinct answer. -1.13e+06. What is the difference between the Aid flow from UN agencies (US$) in Malaysia in 1998 and the Aid flow from UN agencies (US$) in Mozambique in 2000?
Your answer should be compact. -1.28e+06. What is the difference between the Aid flow from UN agencies (US$) of Estonia in 1998 and the Aid flow from UN agencies (US$) of Jamaica in 2001?
Keep it short and to the point. -1.15e+06. What is the difference between the Aid flow from UN agencies (US$) of Estonia in 1998 and the Aid flow from UN agencies (US$) of Malaysia in 2001?
Provide a short and direct response. -1.00e+06. What is the difference between the Aid flow from UN agencies (US$) in Estonia in 1998 and the Aid flow from UN agencies (US$) in Mozambique in 2001?
Offer a terse response. -1.13e+06. What is the difference between the Aid flow from UN agencies (US$) of Jamaica in 1998 and the Aid flow from UN agencies (US$) of Mozambique in 2001?
Provide a succinct answer. -2.40e+05. What is the difference between the Aid flow from UN agencies (US$) in Malaysia in 1998 and the Aid flow from UN agencies (US$) in Mozambique in 2001?
Keep it short and to the point. -3.90e+05. What is the difference between the Aid flow from UN agencies (US$) in Estonia in 1999 and the Aid flow from UN agencies (US$) in Jamaica in 2000?
Offer a terse response. -1.92e+06. What is the difference between the Aid flow from UN agencies (US$) of Estonia in 1999 and the Aid flow from UN agencies (US$) of Malaysia in 2000?
Give a very brief answer. -1.19e+06. What is the difference between the Aid flow from UN agencies (US$) in Estonia in 1999 and the Aid flow from UN agencies (US$) in Mozambique in 2000?
Offer a terse response. -2.13e+06. What is the difference between the Aid flow from UN agencies (US$) of Jamaica in 1999 and the Aid flow from UN agencies (US$) of Mozambique in 2000?
Keep it short and to the point. -4.60e+05. What is the difference between the Aid flow from UN agencies (US$) of Malaysia in 1999 and the Aid flow from UN agencies (US$) of Mozambique in 2000?
Keep it short and to the point. -7.70e+05. What is the difference between the Aid flow from UN agencies (US$) in Estonia in 1999 and the Aid flow from UN agencies (US$) in Jamaica in 2001?
Provide a succinct answer. -1.26e+06. What is the difference between the Aid flow from UN agencies (US$) of Estonia in 1999 and the Aid flow from UN agencies (US$) of Malaysia in 2001?
Your response must be concise. -1.11e+06. What is the difference between the Aid flow from UN agencies (US$) of Estonia in 1999 and the Aid flow from UN agencies (US$) of Mozambique in 2001?
Ensure brevity in your answer.  -1.24e+06. What is the difference between the Aid flow from UN agencies (US$) of Jamaica in 1999 and the Aid flow from UN agencies (US$) of Malaysia in 2001?
Ensure brevity in your answer.  5.60e+05. What is the difference between the Aid flow from UN agencies (US$) of Jamaica in 1999 and the Aid flow from UN agencies (US$) of Mozambique in 2001?
Your response must be concise. 4.30e+05. What is the difference between the Aid flow from UN agencies (US$) in Malaysia in 1999 and the Aid flow from UN agencies (US$) in Mozambique in 2001?
Provide a short and direct response. 1.20e+05. What is the difference between the Aid flow from UN agencies (US$) of Estonia in 2000 and the Aid flow from UN agencies (US$) of Jamaica in 2001?
Ensure brevity in your answer.  -1.21e+06. What is the difference between the Aid flow from UN agencies (US$) in Estonia in 2000 and the Aid flow from UN agencies (US$) in Malaysia in 2001?
Make the answer very short. -1.06e+06. What is the difference between the Aid flow from UN agencies (US$) of Estonia in 2000 and the Aid flow from UN agencies (US$) of Mozambique in 2001?
Give a very brief answer. -1.19e+06. What is the difference between the Aid flow from UN agencies (US$) of Jamaica in 2000 and the Aid flow from UN agencies (US$) of Malaysia in 2001?
Keep it short and to the point. 8.10e+05. What is the difference between the Aid flow from UN agencies (US$) of Jamaica in 2000 and the Aid flow from UN agencies (US$) of Mozambique in 2001?
Ensure brevity in your answer.  6.80e+05. What is the difference between the Aid flow from UN agencies (US$) in Malaysia in 2000 and the Aid flow from UN agencies (US$) in Mozambique in 2001?
Your answer should be compact. -5.00e+04. What is the average Aid flow from UN agencies (US$) in Estonia per year?
Ensure brevity in your answer.  2.28e+05. What is the average Aid flow from UN agencies (US$) of Jamaica per year?
Give a very brief answer. 1.39e+06. What is the average Aid flow from UN agencies (US$) of Malaysia per year?
Provide a short and direct response. 1.39e+06. What is the average Aid flow from UN agencies (US$) of Mozambique per year?
Keep it short and to the point. 1.92e+06. In the year 1994, what is the difference between the Aid flow from UN agencies (US$) in Estonia and Aid flow from UN agencies (US$) in Jamaica?
Provide a succinct answer. -6.80e+05. In the year 1994, what is the difference between the Aid flow from UN agencies (US$) in Estonia and Aid flow from UN agencies (US$) in Malaysia?
Make the answer very short. -9.70e+05. In the year 1994, what is the difference between the Aid flow from UN agencies (US$) in Estonia and Aid flow from UN agencies (US$) in Mozambique?
Keep it short and to the point. -1.17e+06. In the year 1994, what is the difference between the Aid flow from UN agencies (US$) of Jamaica and Aid flow from UN agencies (US$) of Malaysia?
Make the answer very short. -2.90e+05. In the year 1994, what is the difference between the Aid flow from UN agencies (US$) of Jamaica and Aid flow from UN agencies (US$) of Mozambique?
Your answer should be very brief. -4.90e+05. In the year 1995, what is the difference between the Aid flow from UN agencies (US$) in Estonia and Aid flow from UN agencies (US$) in Jamaica?
Your response must be concise. -1.50e+06. In the year 1995, what is the difference between the Aid flow from UN agencies (US$) of Estonia and Aid flow from UN agencies (US$) of Malaysia?
Provide a succinct answer. -2.04e+06. In the year 1995, what is the difference between the Aid flow from UN agencies (US$) of Estonia and Aid flow from UN agencies (US$) of Mozambique?
Offer a terse response. -2.64e+06. In the year 1995, what is the difference between the Aid flow from UN agencies (US$) in Jamaica and Aid flow from UN agencies (US$) in Malaysia?
Make the answer very short. -5.40e+05. In the year 1995, what is the difference between the Aid flow from UN agencies (US$) in Jamaica and Aid flow from UN agencies (US$) in Mozambique?
Your answer should be compact. -1.14e+06. In the year 1995, what is the difference between the Aid flow from UN agencies (US$) of Malaysia and Aid flow from UN agencies (US$) of Mozambique?
Offer a terse response. -6.00e+05. In the year 1996, what is the difference between the Aid flow from UN agencies (US$) in Estonia and Aid flow from UN agencies (US$) in Jamaica?
Provide a succinct answer. -6.90e+05. In the year 1996, what is the difference between the Aid flow from UN agencies (US$) of Estonia and Aid flow from UN agencies (US$) of Malaysia?
Ensure brevity in your answer.  -9.20e+05. In the year 1996, what is the difference between the Aid flow from UN agencies (US$) of Estonia and Aid flow from UN agencies (US$) of Mozambique?
Your response must be concise. -1.81e+06. In the year 1996, what is the difference between the Aid flow from UN agencies (US$) in Jamaica and Aid flow from UN agencies (US$) in Mozambique?
Provide a short and direct response. -1.12e+06. In the year 1996, what is the difference between the Aid flow from UN agencies (US$) in Malaysia and Aid flow from UN agencies (US$) in Mozambique?
Provide a succinct answer. -8.90e+05. In the year 1997, what is the difference between the Aid flow from UN agencies (US$) in Estonia and Aid flow from UN agencies (US$) in Jamaica?
Offer a very short reply. -8.20e+05. In the year 1997, what is the difference between the Aid flow from UN agencies (US$) in Estonia and Aid flow from UN agencies (US$) in Malaysia?
Your answer should be compact. -1.12e+06. In the year 1997, what is the difference between the Aid flow from UN agencies (US$) of Estonia and Aid flow from UN agencies (US$) of Mozambique?
Ensure brevity in your answer.  -1.28e+06. In the year 1997, what is the difference between the Aid flow from UN agencies (US$) of Jamaica and Aid flow from UN agencies (US$) of Mozambique?
Ensure brevity in your answer.  -4.60e+05. In the year 1998, what is the difference between the Aid flow from UN agencies (US$) in Estonia and Aid flow from UN agencies (US$) in Jamaica?
Your answer should be very brief. -8.90e+05. In the year 1998, what is the difference between the Aid flow from UN agencies (US$) in Estonia and Aid flow from UN agencies (US$) in Malaysia?
Provide a succinct answer. -7.40e+05. In the year 1998, what is the difference between the Aid flow from UN agencies (US$) in Estonia and Aid flow from UN agencies (US$) in Mozambique?
Provide a short and direct response. -1.30e+06. In the year 1998, what is the difference between the Aid flow from UN agencies (US$) of Jamaica and Aid flow from UN agencies (US$) of Malaysia?
Ensure brevity in your answer.  1.50e+05. In the year 1998, what is the difference between the Aid flow from UN agencies (US$) of Jamaica and Aid flow from UN agencies (US$) of Mozambique?
Ensure brevity in your answer.  -4.10e+05. In the year 1998, what is the difference between the Aid flow from UN agencies (US$) of Malaysia and Aid flow from UN agencies (US$) of Mozambique?
Provide a succinct answer. -5.60e+05. In the year 1999, what is the difference between the Aid flow from UN agencies (US$) of Estonia and Aid flow from UN agencies (US$) of Jamaica?
Provide a short and direct response. -1.67e+06. In the year 1999, what is the difference between the Aid flow from UN agencies (US$) in Estonia and Aid flow from UN agencies (US$) in Malaysia?
Your answer should be compact. -1.36e+06. In the year 1999, what is the difference between the Aid flow from UN agencies (US$) in Estonia and Aid flow from UN agencies (US$) in Mozambique?
Provide a succinct answer. -2.05e+06. In the year 1999, what is the difference between the Aid flow from UN agencies (US$) of Jamaica and Aid flow from UN agencies (US$) of Mozambique?
Provide a short and direct response. -3.80e+05. In the year 1999, what is the difference between the Aid flow from UN agencies (US$) in Malaysia and Aid flow from UN agencies (US$) in Mozambique?
Offer a very short reply. -6.90e+05. In the year 2000, what is the difference between the Aid flow from UN agencies (US$) of Estonia and Aid flow from UN agencies (US$) of Jamaica?
Provide a succinct answer. -1.87e+06. In the year 2000, what is the difference between the Aid flow from UN agencies (US$) of Estonia and Aid flow from UN agencies (US$) of Malaysia?
Your answer should be very brief. -1.14e+06. In the year 2000, what is the difference between the Aid flow from UN agencies (US$) of Estonia and Aid flow from UN agencies (US$) of Mozambique?
Provide a succinct answer. -2.08e+06. In the year 2000, what is the difference between the Aid flow from UN agencies (US$) in Jamaica and Aid flow from UN agencies (US$) in Malaysia?
Your answer should be very brief. 7.30e+05. In the year 2000, what is the difference between the Aid flow from UN agencies (US$) of Jamaica and Aid flow from UN agencies (US$) of Mozambique?
Keep it short and to the point. -2.10e+05. In the year 2000, what is the difference between the Aid flow from UN agencies (US$) in Malaysia and Aid flow from UN agencies (US$) in Mozambique?
Make the answer very short. -9.40e+05. In the year 2001, what is the difference between the Aid flow from UN agencies (US$) of Estonia and Aid flow from UN agencies (US$) of Jamaica?
Provide a short and direct response. -1.19e+06. In the year 2001, what is the difference between the Aid flow from UN agencies (US$) of Estonia and Aid flow from UN agencies (US$) of Malaysia?
Your answer should be very brief. -1.04e+06. In the year 2001, what is the difference between the Aid flow from UN agencies (US$) of Estonia and Aid flow from UN agencies (US$) of Mozambique?
Your answer should be compact. -1.17e+06. In the year 2001, what is the difference between the Aid flow from UN agencies (US$) in Jamaica and Aid flow from UN agencies (US$) in Malaysia?
Provide a succinct answer. 1.50e+05. In the year 2001, what is the difference between the Aid flow from UN agencies (US$) of Malaysia and Aid flow from UN agencies (US$) of Mozambique?
Keep it short and to the point. -1.30e+05. What is the ratio of the Aid flow from UN agencies (US$) in Estonia in 1994 to that in 1995?
Offer a terse response. 0.51. What is the ratio of the Aid flow from UN agencies (US$) of Jamaica in 1994 to that in 1995?
Provide a succinct answer. 0.47. What is the ratio of the Aid flow from UN agencies (US$) in Malaysia in 1994 to that in 1995?
Give a very brief answer. 0.48. What is the ratio of the Aid flow from UN agencies (US$) of Mozambique in 1994 to that in 1995?
Your answer should be compact. 0.45. What is the ratio of the Aid flow from UN agencies (US$) in Estonia in 1994 to that in 1996?
Keep it short and to the point. 0.7. What is the ratio of the Aid flow from UN agencies (US$) of Jamaica in 1994 to that in 1996?
Make the answer very short. 0.91. What is the ratio of the Aid flow from UN agencies (US$) of Malaysia in 1994 to that in 1996?
Offer a very short reply. 0.97. What is the ratio of the Aid flow from UN agencies (US$) in Mozambique in 1994 to that in 1996?
Offer a terse response. 0.65. What is the ratio of the Aid flow from UN agencies (US$) in Estonia in 1994 to that in 1997?
Provide a succinct answer. 0.43. What is the ratio of the Aid flow from UN agencies (US$) in Jamaica in 1994 to that in 1997?
Provide a short and direct response. 0.69. What is the ratio of the Aid flow from UN agencies (US$) in Malaysia in 1994 to that in 1997?
Offer a terse response. 0.74. What is the ratio of the Aid flow from UN agencies (US$) in Mozambique in 1994 to that in 1997?
Offer a terse response. 0.79. What is the ratio of the Aid flow from UN agencies (US$) of Jamaica in 1994 to that in 1998?
Make the answer very short. 0.81. What is the ratio of the Aid flow from UN agencies (US$) in Malaysia in 1994 to that in 1998?
Provide a short and direct response. 1.25. What is the ratio of the Aid flow from UN agencies (US$) of Mozambique in 1994 to that in 1998?
Ensure brevity in your answer.  0.91. What is the ratio of the Aid flow from UN agencies (US$) of Estonia in 1994 to that in 1999?
Your answer should be very brief. 2.38. What is the ratio of the Aid flow from UN agencies (US$) of Jamaica in 1994 to that in 1999?
Ensure brevity in your answer.  0.5. What is the ratio of the Aid flow from UN agencies (US$) in Malaysia in 1994 to that in 1999?
Ensure brevity in your answer.  0.81. What is the ratio of the Aid flow from UN agencies (US$) in Mozambique in 1994 to that in 1999?
Your answer should be very brief. 0.64. What is the ratio of the Aid flow from UN agencies (US$) in Estonia in 1994 to that in 2000?
Offer a terse response. 1.46. What is the ratio of the Aid flow from UN agencies (US$) in Jamaica in 1994 to that in 2000?
Offer a very short reply. 0.43. What is the ratio of the Aid flow from UN agencies (US$) of Malaysia in 1994 to that in 2000?
Offer a terse response. 0.91. What is the ratio of the Aid flow from UN agencies (US$) of Mozambique in 1994 to that in 2000?
Offer a terse response. 0.62. What is the ratio of the Aid flow from UN agencies (US$) in Estonia in 1994 to that in 2001?
Make the answer very short. 1.27. What is the ratio of the Aid flow from UN agencies (US$) in Jamaica in 1994 to that in 2001?
Offer a very short reply. 0.65. What is the ratio of the Aid flow from UN agencies (US$) of Malaysia in 1994 to that in 2001?
Ensure brevity in your answer.  0.97. What is the ratio of the Aid flow from UN agencies (US$) in Mozambique in 1994 to that in 2001?
Keep it short and to the point. 1.03. What is the ratio of the Aid flow from UN agencies (US$) of Estonia in 1995 to that in 1996?
Ensure brevity in your answer.  1.37. What is the ratio of the Aid flow from UN agencies (US$) of Jamaica in 1995 to that in 1996?
Your answer should be compact. 1.95. What is the ratio of the Aid flow from UN agencies (US$) in Malaysia in 1995 to that in 1996?
Give a very brief answer. 2.03. What is the ratio of the Aid flow from UN agencies (US$) in Mozambique in 1995 to that in 1996?
Your answer should be very brief. 1.45. What is the ratio of the Aid flow from UN agencies (US$) of Estonia in 1995 to that in 1997?
Offer a very short reply. 0.84. What is the ratio of the Aid flow from UN agencies (US$) in Jamaica in 1995 to that in 1997?
Offer a terse response. 1.48. What is the ratio of the Aid flow from UN agencies (US$) in Malaysia in 1995 to that in 1997?
Your response must be concise. 1.54. What is the ratio of the Aid flow from UN agencies (US$) in Estonia in 1995 to that in 1998?
Provide a succinct answer. 1.95. What is the ratio of the Aid flow from UN agencies (US$) in Jamaica in 1995 to that in 1998?
Offer a very short reply. 1.73. What is the ratio of the Aid flow from UN agencies (US$) in Malaysia in 1995 to that in 1998?
Offer a terse response. 2.59. What is the ratio of the Aid flow from UN agencies (US$) in Mozambique in 1995 to that in 1998?
Ensure brevity in your answer.  2.02. What is the ratio of the Aid flow from UN agencies (US$) in Estonia in 1995 to that in 1999?
Your response must be concise. 4.62. What is the ratio of the Aid flow from UN agencies (US$) in Jamaica in 1995 to that in 1999?
Your answer should be very brief. 1.07. What is the ratio of the Aid flow from UN agencies (US$) of Malaysia in 1995 to that in 1999?
Provide a short and direct response. 1.67. What is the ratio of the Aid flow from UN agencies (US$) of Mozambique in 1995 to that in 1999?
Your answer should be very brief. 1.41. What is the ratio of the Aid flow from UN agencies (US$) in Estonia in 1995 to that in 2000?
Offer a very short reply. 2.85. What is the ratio of the Aid flow from UN agencies (US$) in Jamaica in 1995 to that in 2000?
Your answer should be very brief. 0.94. What is the ratio of the Aid flow from UN agencies (US$) of Malaysia in 1995 to that in 2000?
Give a very brief answer. 1.9. What is the ratio of the Aid flow from UN agencies (US$) of Mozambique in 1995 to that in 2000?
Offer a very short reply. 1.36. What is the ratio of the Aid flow from UN agencies (US$) in Estonia in 1995 to that in 2001?
Your answer should be compact. 2.47. What is the ratio of the Aid flow from UN agencies (US$) in Jamaica in 1995 to that in 2001?
Ensure brevity in your answer.  1.4. What is the ratio of the Aid flow from UN agencies (US$) of Malaysia in 1995 to that in 2001?
Your response must be concise. 2.03. What is the ratio of the Aid flow from UN agencies (US$) in Mozambique in 1995 to that in 2001?
Give a very brief answer. 2.28. What is the ratio of the Aid flow from UN agencies (US$) of Estonia in 1996 to that in 1997?
Your answer should be very brief. 0.61. What is the ratio of the Aid flow from UN agencies (US$) of Jamaica in 1996 to that in 1997?
Provide a succinct answer. 0.76. What is the ratio of the Aid flow from UN agencies (US$) of Malaysia in 1996 to that in 1997?
Offer a terse response. 0.76. What is the ratio of the Aid flow from UN agencies (US$) in Mozambique in 1996 to that in 1997?
Keep it short and to the point. 1.21. What is the ratio of the Aid flow from UN agencies (US$) of Estonia in 1996 to that in 1998?
Offer a terse response. 1.42. What is the ratio of the Aid flow from UN agencies (US$) in Jamaica in 1996 to that in 1998?
Give a very brief answer. 0.89. What is the ratio of the Aid flow from UN agencies (US$) of Malaysia in 1996 to that in 1998?
Your answer should be compact. 1.28. What is the ratio of the Aid flow from UN agencies (US$) in Mozambique in 1996 to that in 1998?
Your response must be concise. 1.4. What is the ratio of the Aid flow from UN agencies (US$) in Estonia in 1996 to that in 1999?
Offer a very short reply. 3.38. What is the ratio of the Aid flow from UN agencies (US$) in Jamaica in 1996 to that in 1999?
Provide a succinct answer. 0.55. What is the ratio of the Aid flow from UN agencies (US$) of Malaysia in 1996 to that in 1999?
Keep it short and to the point. 0.83. What is the ratio of the Aid flow from UN agencies (US$) of Mozambique in 1996 to that in 1999?
Keep it short and to the point. 0.98. What is the ratio of the Aid flow from UN agencies (US$) in Estonia in 1996 to that in 2000?
Give a very brief answer. 2.08. What is the ratio of the Aid flow from UN agencies (US$) of Jamaica in 1996 to that in 2000?
Keep it short and to the point. 0.48. What is the ratio of the Aid flow from UN agencies (US$) in Malaysia in 1996 to that in 2000?
Provide a short and direct response. 0.94. What is the ratio of the Aid flow from UN agencies (US$) of Mozambique in 1996 to that in 2000?
Keep it short and to the point. 0.94. What is the ratio of the Aid flow from UN agencies (US$) in Estonia in 1996 to that in 2001?
Your answer should be compact. 1.8. What is the ratio of the Aid flow from UN agencies (US$) of Jamaica in 1996 to that in 2001?
Your response must be concise. 0.72. What is the ratio of the Aid flow from UN agencies (US$) in Malaysia in 1996 to that in 2001?
Ensure brevity in your answer.  1. What is the ratio of the Aid flow from UN agencies (US$) of Mozambique in 1996 to that in 2001?
Offer a terse response. 1.58. What is the ratio of the Aid flow from UN agencies (US$) in Estonia in 1997 to that in 1998?
Your answer should be compact. 2.32. What is the ratio of the Aid flow from UN agencies (US$) of Jamaica in 1997 to that in 1998?
Ensure brevity in your answer.  1.17. What is the ratio of the Aid flow from UN agencies (US$) in Malaysia in 1997 to that in 1998?
Offer a terse response. 1.68. What is the ratio of the Aid flow from UN agencies (US$) of Mozambique in 1997 to that in 1998?
Your answer should be compact. 1.15. What is the ratio of the Aid flow from UN agencies (US$) in Jamaica in 1997 to that in 1999?
Offer a very short reply. 0.72. What is the ratio of the Aid flow from UN agencies (US$) of Malaysia in 1997 to that in 1999?
Provide a short and direct response. 1.08. What is the ratio of the Aid flow from UN agencies (US$) of Mozambique in 1997 to that in 1999?
Give a very brief answer. 0.81. What is the ratio of the Aid flow from UN agencies (US$) in Estonia in 1997 to that in 2000?
Provide a succinct answer. 3.38. What is the ratio of the Aid flow from UN agencies (US$) in Jamaica in 1997 to that in 2000?
Offer a terse response. 0.63. What is the ratio of the Aid flow from UN agencies (US$) of Malaysia in 1997 to that in 2000?
Ensure brevity in your answer.  1.23. What is the ratio of the Aid flow from UN agencies (US$) in Mozambique in 1997 to that in 2000?
Keep it short and to the point. 0.78. What is the ratio of the Aid flow from UN agencies (US$) in Estonia in 1997 to that in 2001?
Your answer should be very brief. 2.93. What is the ratio of the Aid flow from UN agencies (US$) in Jamaica in 1997 to that in 2001?
Make the answer very short. 0.94. What is the ratio of the Aid flow from UN agencies (US$) in Malaysia in 1997 to that in 2001?
Offer a very short reply. 1.31. What is the ratio of the Aid flow from UN agencies (US$) of Mozambique in 1997 to that in 2001?
Your response must be concise. 1.3. What is the ratio of the Aid flow from UN agencies (US$) of Estonia in 1998 to that in 1999?
Your response must be concise. 2.38. What is the ratio of the Aid flow from UN agencies (US$) in Jamaica in 1998 to that in 1999?
Your response must be concise. 0.62. What is the ratio of the Aid flow from UN agencies (US$) of Malaysia in 1998 to that in 1999?
Your answer should be very brief. 0.65. What is the ratio of the Aid flow from UN agencies (US$) of Mozambique in 1998 to that in 1999?
Your answer should be compact. 0.7. What is the ratio of the Aid flow from UN agencies (US$) of Estonia in 1998 to that in 2000?
Make the answer very short. 1.46. What is the ratio of the Aid flow from UN agencies (US$) in Jamaica in 1998 to that in 2000?
Your answer should be compact. 0.54. What is the ratio of the Aid flow from UN agencies (US$) in Malaysia in 1998 to that in 2000?
Provide a succinct answer. 0.73. What is the ratio of the Aid flow from UN agencies (US$) in Mozambique in 1998 to that in 2000?
Ensure brevity in your answer.  0.67. What is the ratio of the Aid flow from UN agencies (US$) of Estonia in 1998 to that in 2001?
Offer a terse response. 1.27. What is the ratio of the Aid flow from UN agencies (US$) in Jamaica in 1998 to that in 2001?
Your answer should be compact. 0.81. What is the ratio of the Aid flow from UN agencies (US$) in Malaysia in 1998 to that in 2001?
Your response must be concise. 0.78. What is the ratio of the Aid flow from UN agencies (US$) of Mozambique in 1998 to that in 2001?
Your answer should be compact. 1.13. What is the ratio of the Aid flow from UN agencies (US$) in Estonia in 1999 to that in 2000?
Offer a very short reply. 0.62. What is the ratio of the Aid flow from UN agencies (US$) in Jamaica in 1999 to that in 2000?
Give a very brief answer. 0.88. What is the ratio of the Aid flow from UN agencies (US$) in Malaysia in 1999 to that in 2000?
Keep it short and to the point. 1.13. What is the ratio of the Aid flow from UN agencies (US$) in Mozambique in 1999 to that in 2000?
Ensure brevity in your answer.  0.96. What is the ratio of the Aid flow from UN agencies (US$) in Estonia in 1999 to that in 2001?
Provide a short and direct response. 0.53. What is the ratio of the Aid flow from UN agencies (US$) of Jamaica in 1999 to that in 2001?
Provide a succinct answer. 1.31. What is the ratio of the Aid flow from UN agencies (US$) in Malaysia in 1999 to that in 2001?
Provide a short and direct response. 1.21. What is the ratio of the Aid flow from UN agencies (US$) in Mozambique in 1999 to that in 2001?
Ensure brevity in your answer.  1.61. What is the ratio of the Aid flow from UN agencies (US$) of Estonia in 2000 to that in 2001?
Provide a short and direct response. 0.87. What is the ratio of the Aid flow from UN agencies (US$) of Jamaica in 2000 to that in 2001?
Offer a terse response. 1.49. What is the ratio of the Aid flow from UN agencies (US$) of Malaysia in 2000 to that in 2001?
Provide a short and direct response. 1.07. What is the ratio of the Aid flow from UN agencies (US$) of Mozambique in 2000 to that in 2001?
Offer a very short reply. 1.67. What is the difference between the highest and the second highest Aid flow from UN agencies (US$) of Estonia?
Provide a succinct answer. 7.00e+04. What is the difference between the highest and the second highest Aid flow from UN agencies (US$) in Malaysia?
Your answer should be compact. 8.50e+05. What is the difference between the highest and the second highest Aid flow from UN agencies (US$) of Mozambique?
Provide a succinct answer. 8.00e+05. What is the difference between the highest and the lowest Aid flow from UN agencies (US$) of Estonia?
Your answer should be very brief. 3.60e+05. What is the difference between the highest and the lowest Aid flow from UN agencies (US$) in Jamaica?
Provide a succinct answer. 1.13e+06. What is the difference between the highest and the lowest Aid flow from UN agencies (US$) of Malaysia?
Provide a succinct answer. 1.48e+06. What is the difference between the highest and the lowest Aid flow from UN agencies (US$) of Mozambique?
Ensure brevity in your answer.  1.69e+06. 